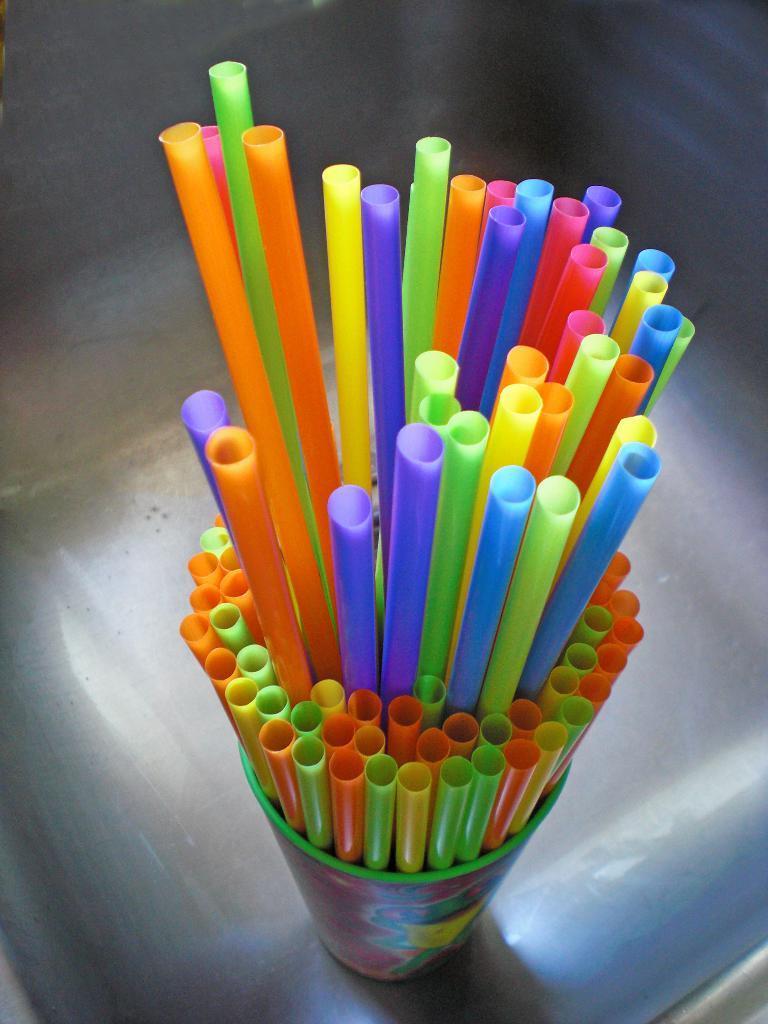Please provide a concise description of this image. In this image we can see some different colors of pipes in a glass, and it is placed on the surface. 